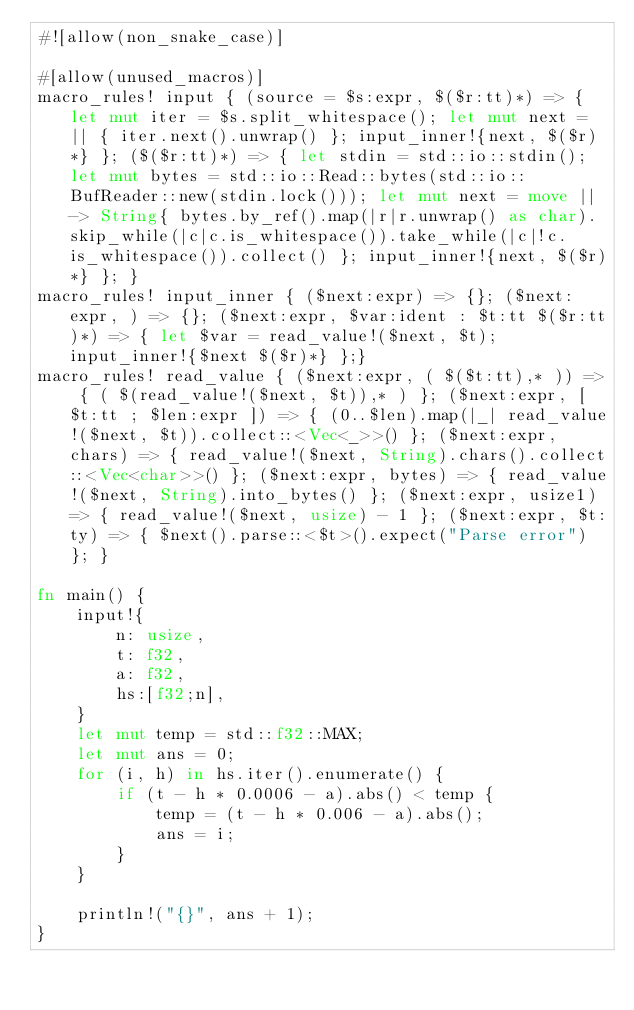<code> <loc_0><loc_0><loc_500><loc_500><_Rust_>#![allow(non_snake_case)]

#[allow(unused_macros)]
macro_rules! input { (source = $s:expr, $($r:tt)*) => { let mut iter = $s.split_whitespace(); let mut next = || { iter.next().unwrap() }; input_inner!{next, $($r)*} }; ($($r:tt)*) => { let stdin = std::io::stdin(); let mut bytes = std::io::Read::bytes(std::io::BufReader::new(stdin.lock())); let mut next = move || -> String{ bytes.by_ref().map(|r|r.unwrap() as char).skip_while(|c|c.is_whitespace()).take_while(|c|!c.is_whitespace()).collect() }; input_inner!{next, $($r)*} }; }
macro_rules! input_inner { ($next:expr) => {}; ($next:expr, ) => {}; ($next:expr, $var:ident : $t:tt $($r:tt)*) => { let $var = read_value!($next, $t); input_inner!{$next $($r)*} };}
macro_rules! read_value { ($next:expr, ( $($t:tt),* )) => { ( $(read_value!($next, $t)),* ) }; ($next:expr, [ $t:tt ; $len:expr ]) => { (0..$len).map(|_| read_value!($next, $t)).collect::<Vec<_>>() }; ($next:expr, chars) => { read_value!($next, String).chars().collect::<Vec<char>>() }; ($next:expr, bytes) => { read_value!($next, String).into_bytes() }; ($next:expr, usize1) => { read_value!($next, usize) - 1 }; ($next:expr, $t:ty) => { $next().parse::<$t>().expect("Parse error") }; }

fn main() {
    input!{
        n: usize,
        t: f32,
        a: f32,
        hs:[f32;n],
    }
    let mut temp = std::f32::MAX;
    let mut ans = 0;
    for (i, h) in hs.iter().enumerate() {
        if (t - h * 0.0006 - a).abs() < temp {
            temp = (t - h * 0.006 - a).abs();
            ans = i;
        }
    }

    println!("{}", ans + 1);
}</code> 